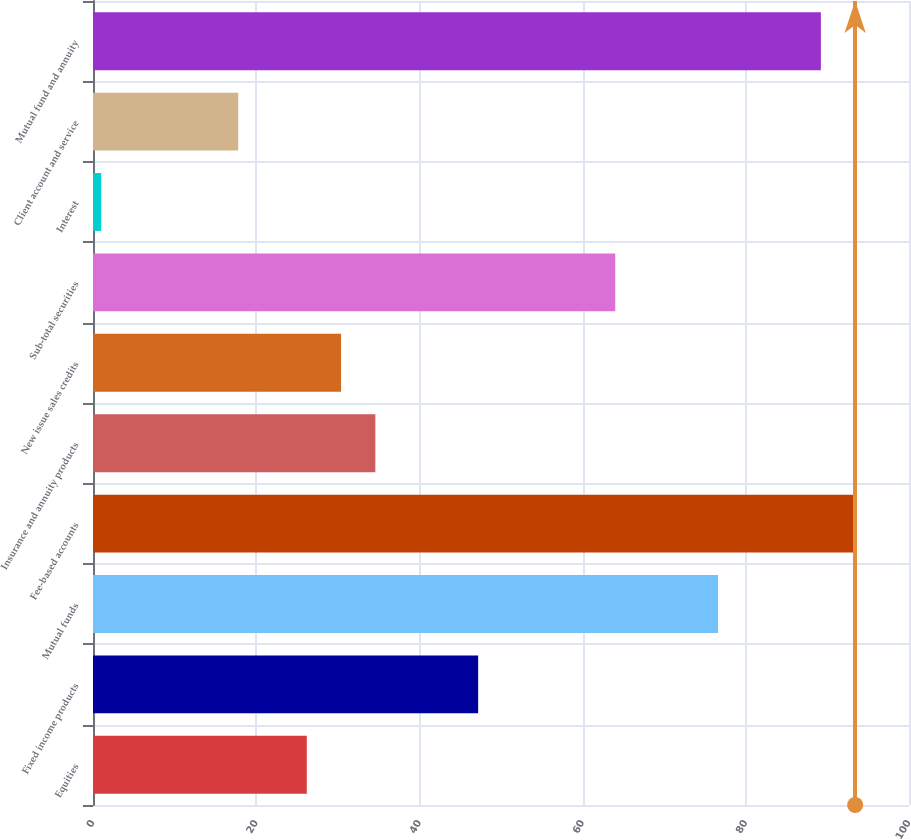Convert chart. <chart><loc_0><loc_0><loc_500><loc_500><bar_chart><fcel>Equities<fcel>Fixed income products<fcel>Mutual funds<fcel>Fee-based accounts<fcel>Insurance and annuity products<fcel>New issue sales credits<fcel>Sub-total securities<fcel>Interest<fcel>Client account and service<fcel>Mutual fund and annuity<nl><fcel>26.2<fcel>47.2<fcel>76.6<fcel>93.4<fcel>34.6<fcel>30.4<fcel>64<fcel>1<fcel>17.8<fcel>89.2<nl></chart> 